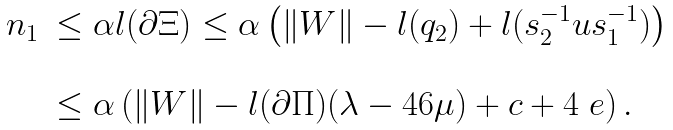<formula> <loc_0><loc_0><loc_500><loc_500>\begin{array} { r l } n _ { 1 } & \leq \alpha l ( \partial \Xi ) \leq \alpha \left ( \| W \| - l ( q _ { 2 } ) + l ( s _ { 2 } ^ { - 1 } u s _ { 1 } ^ { - 1 } ) \right ) \\ & \\ & \leq \alpha \left ( \| W \| - l ( \partial \Pi ) ( \lambda - 4 6 \mu ) + c + 4 \ e \right ) . \end{array}</formula> 